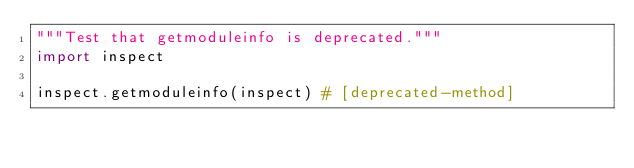Convert code to text. <code><loc_0><loc_0><loc_500><loc_500><_Python_>"""Test that getmoduleinfo is deprecated."""
import inspect

inspect.getmoduleinfo(inspect) # [deprecated-method]
</code> 